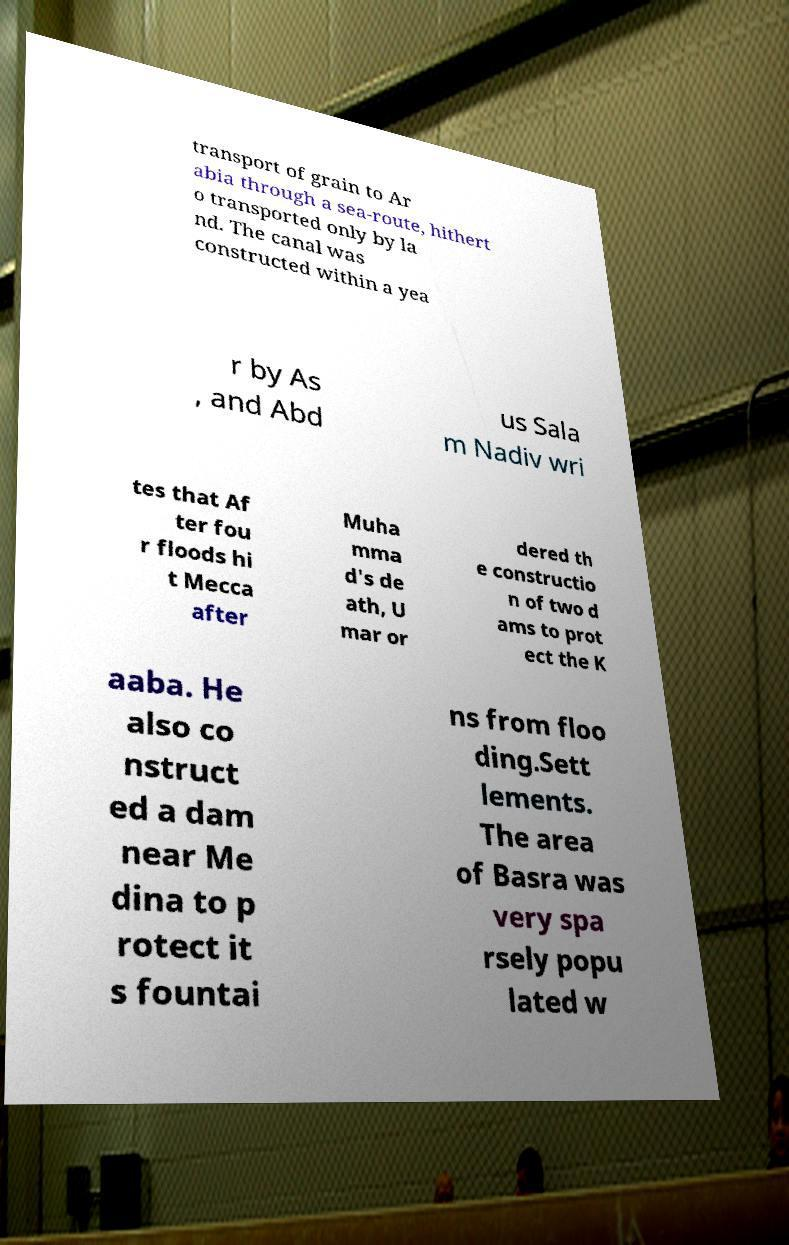For documentation purposes, I need the text within this image transcribed. Could you provide that? transport of grain to Ar abia through a sea-route, hithert o transported only by la nd. The canal was constructed within a yea r by As , and Abd us Sala m Nadiv wri tes that Af ter fou r floods hi t Mecca after Muha mma d's de ath, U mar or dered th e constructio n of two d ams to prot ect the K aaba. He also co nstruct ed a dam near Me dina to p rotect it s fountai ns from floo ding.Sett lements. The area of Basra was very spa rsely popu lated w 